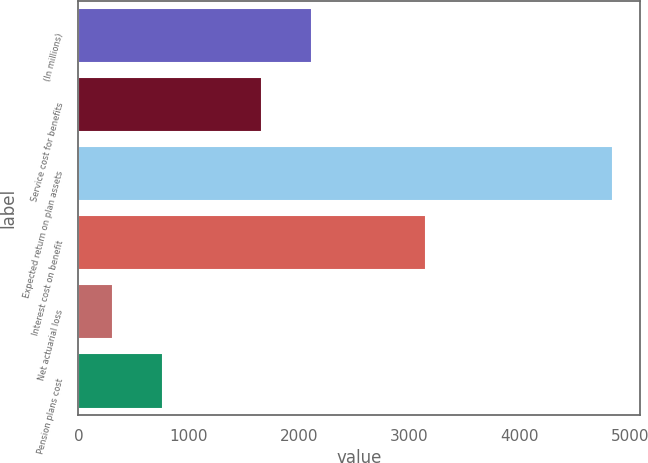<chart> <loc_0><loc_0><loc_500><loc_500><bar_chart><fcel>(In millions)<fcel>Service cost for benefits<fcel>Expected return on plan assets<fcel>Interest cost on benefit<fcel>Net actuarial loss<fcel>Pension plans cost<nl><fcel>2116.4<fcel>1663<fcel>4850<fcel>3152<fcel>316<fcel>769.4<nl></chart> 